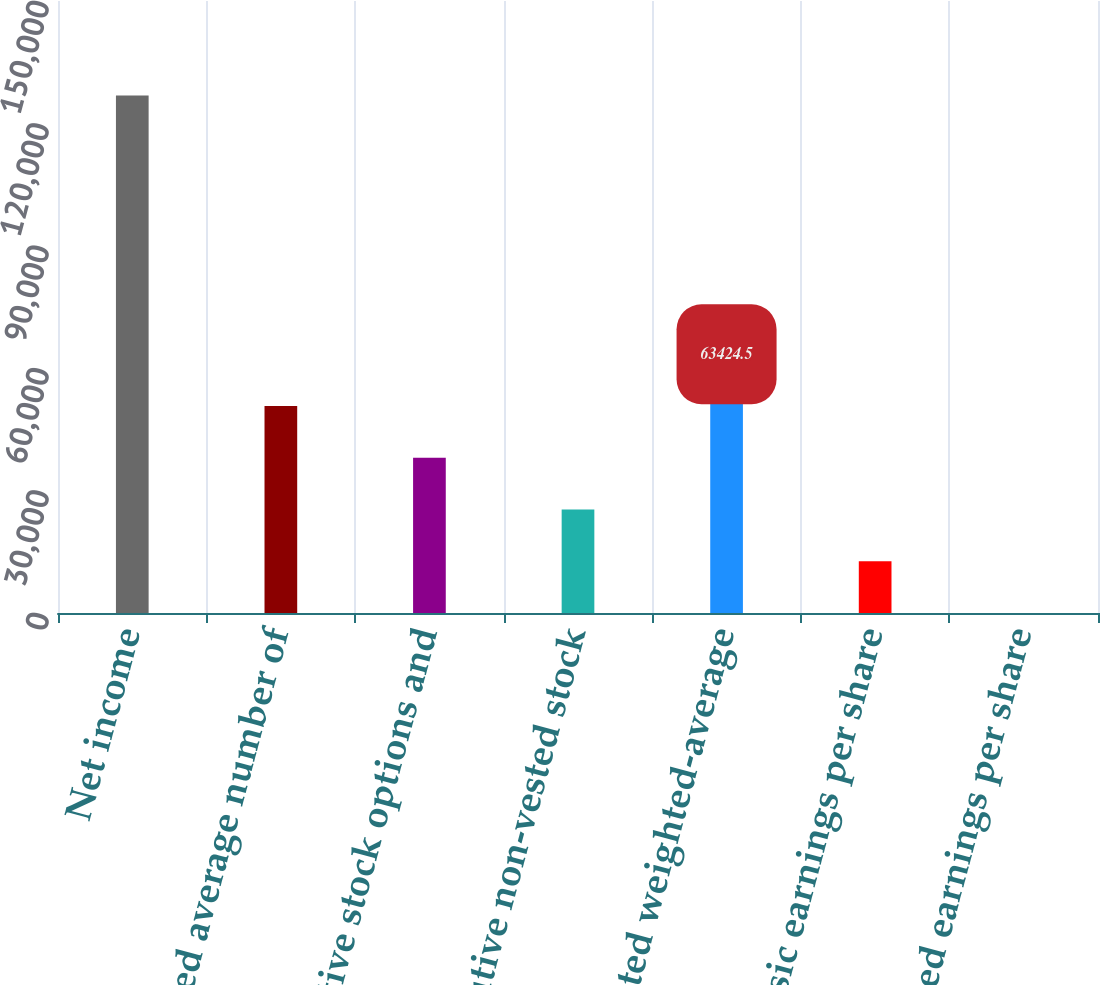Convert chart. <chart><loc_0><loc_0><loc_500><loc_500><bar_chart><fcel>Net income<fcel>Weighted average number of<fcel>Dilutive stock options and<fcel>Dilutive non-vested stock<fcel>Diluted weighted-average<fcel>Basic earnings per share<fcel>Diluted earnings per share<nl><fcel>126845<fcel>50740.4<fcel>38056.3<fcel>25372.2<fcel>63424.5<fcel>12688.1<fcel>3.95<nl></chart> 